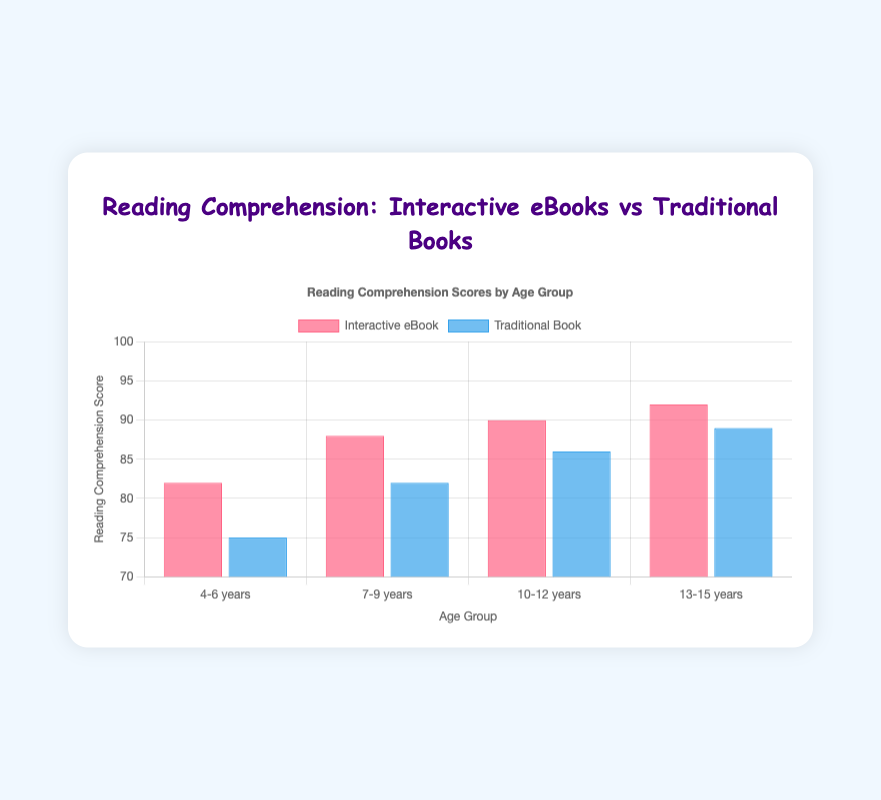What is the difference in the average reading comprehension score for the age group 4-6 years between Interactive eBooks and Traditional Books? The average score for Interactive eBooks in the 4-6 years age group is 82, while for Traditional Books it is 75. The difference is 82 - 75 = 7
Answer: 7 Which age group shows the highest reading comprehension score for Interactive eBooks? Comparing the average scores for all age groups, 4-6 years has 82, 7-9 years has 88, 10-12 years has 90, and 13-15 years has 92. The highest score is for the 13-15 years age group with a score of 92
Answer: 13-15 years Between which two age groups is the smallest difference in reading comprehension scores for Traditional Books? The scores for Traditional Books are as follows: 4-6 years: 75, 7-9 years: 82, 10-12 years: 86, and 13-15 years: 89. The differences are 82-75=7, 86-82=4, and 89-86=3. The smallest difference is between 10-12 years and 13-15 years, which is 3
Answer: 10-12 years and 13-15 years What is the average reading comprehension score for Interactive eBooks across all age groups? The scores for Interactive eBooks are 82, 88, 90, and 92. The average score is calculated as (82 + 88 + 90 + 92) / 4 = 88
Answer: 88 Which bar is taller in the age group 10-12 years: Interactive eBooks or Traditional Books? In the age group 10-12 years, the score for Interactive eBooks is 90, while the score for Traditional Books is 86. The bar for Interactive eBooks is taller
Answer: Interactive eBooks Which age group has the smallest difference in reading comprehension scores between Interactive eBooks and Traditional Books? The difference scores are: 4-6 years: 82-75=7, 7-9 years: 88-82=6, 10-12 years: 90-86=4, 13-15 years: 92-89=3. The smallest difference is in the 13-15 years group with a difference of 3
Answer: 13-15 years Is the reading comprehension score for Traditional Books in the 7-9 years age group higher than the reading comprehension score for Interactive eBooks in the 4-6 years age group? Scores are 82 for Interactive eBooks in 4-6 years and 82 for Traditional Books in 7-9 years. Both scores are equal
Answer: No, they are equal What is the combined total of the reading comprehension scores for the age groups 4-6 years and 7-9 years for Interactive eBooks? Adding scores for 4-6 years (82) and 7-9 years (88), the combined total is 82 + 88 = 170
Answer: 170 